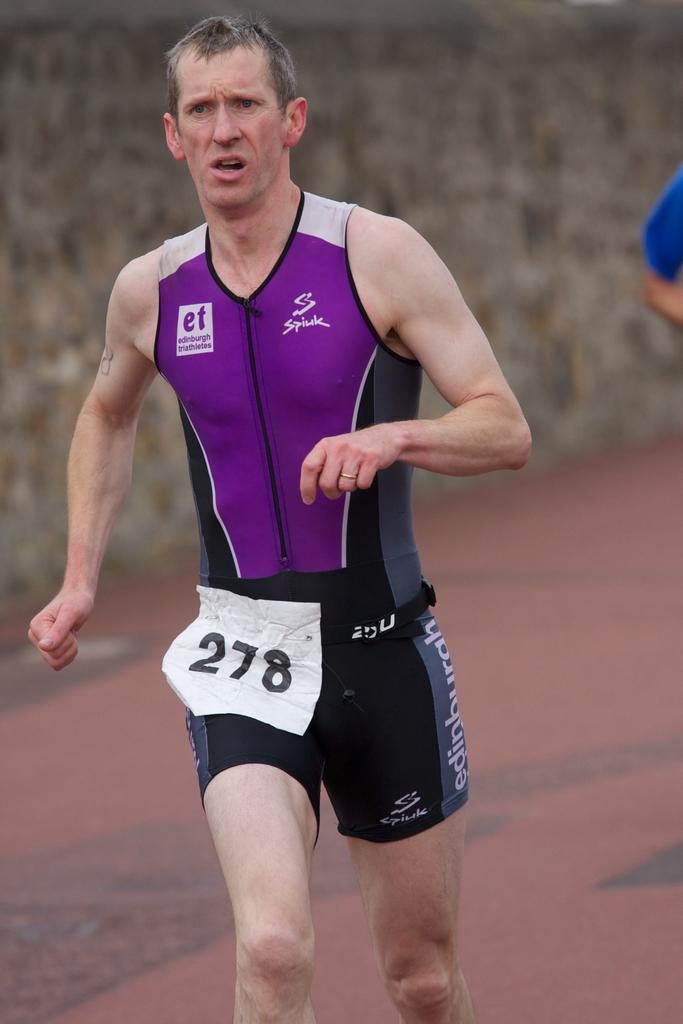<image>
Offer a succinct explanation of the picture presented. A runner wearing a number 278 tag is competing in a race. 